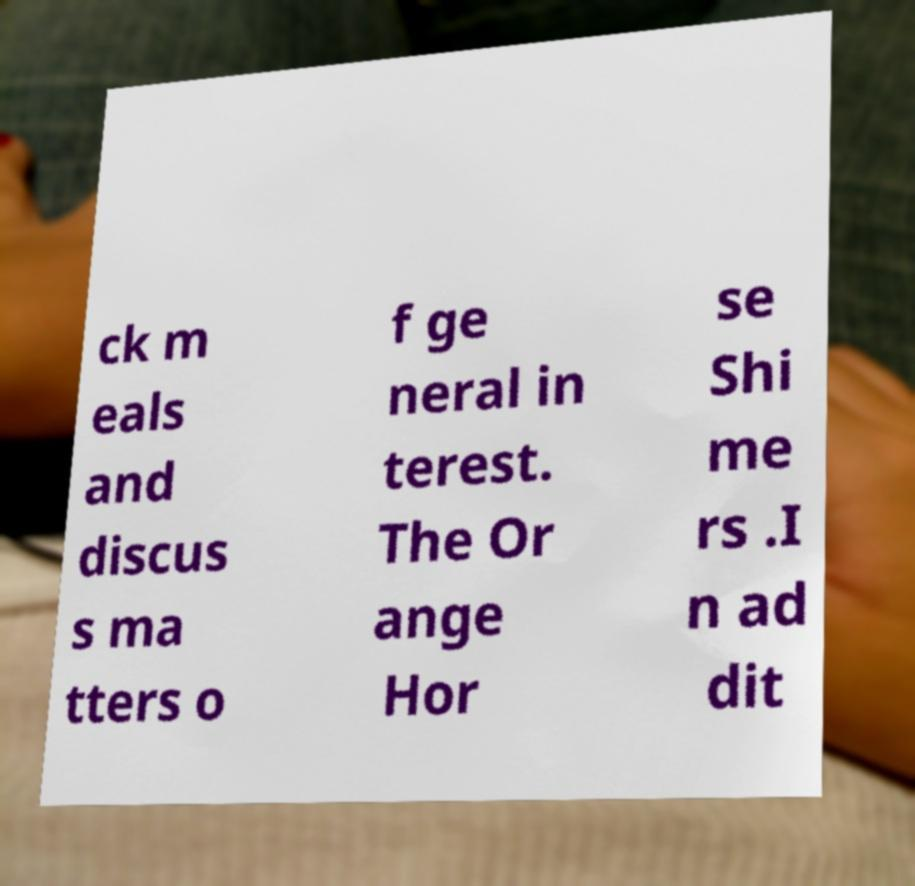What messages or text are displayed in this image? I need them in a readable, typed format. ck m eals and discus s ma tters o f ge neral in terest. The Or ange Hor se Shi me rs .I n ad dit 